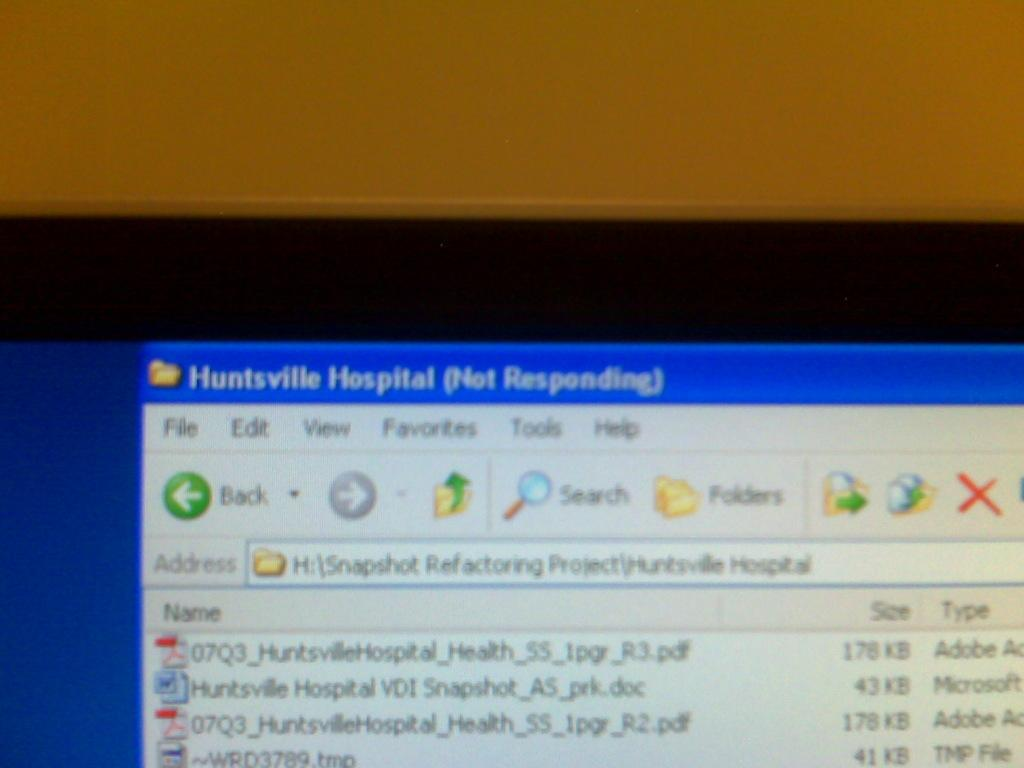<image>
Render a clear and concise summary of the photo. A file named Huntsville Hospital that is not responding. 